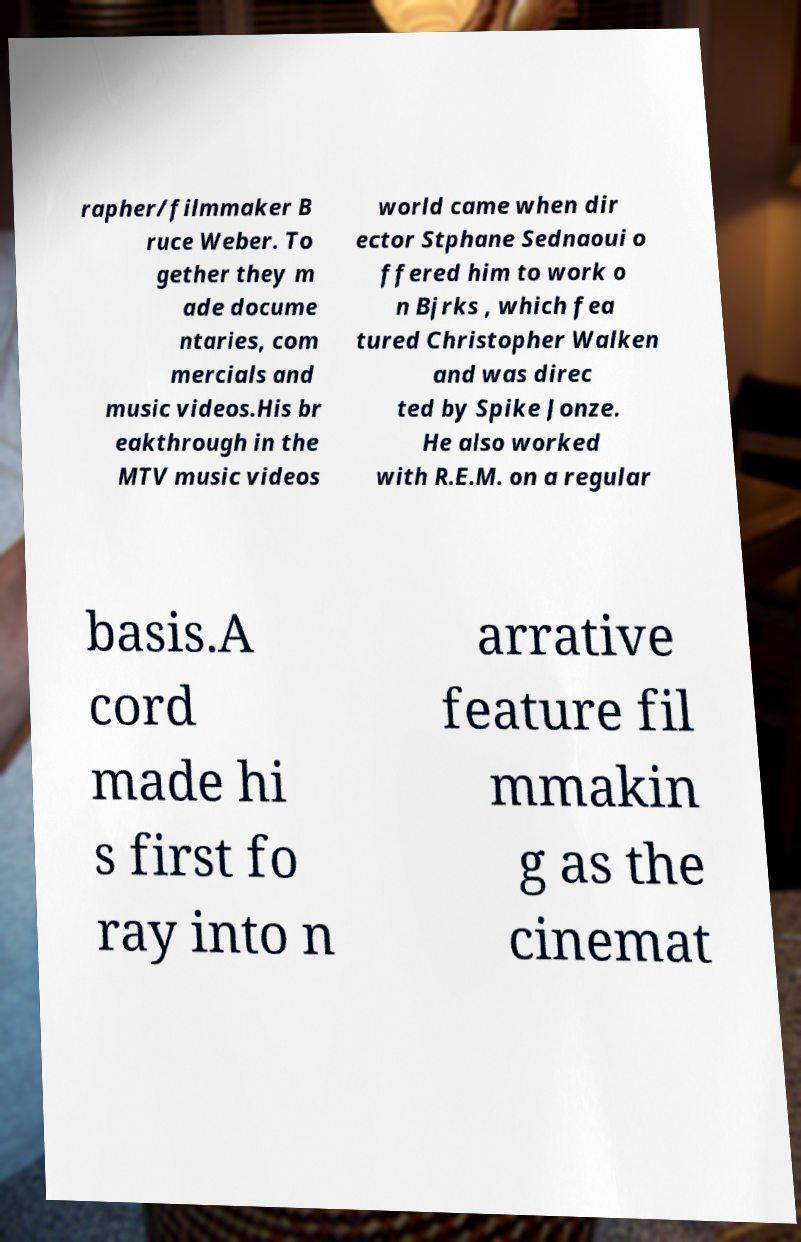What messages or text are displayed in this image? I need them in a readable, typed format. rapher/filmmaker B ruce Weber. To gether they m ade docume ntaries, com mercials and music videos.His br eakthrough in the MTV music videos world came when dir ector Stphane Sednaoui o ffered him to work o n Bjrks , which fea tured Christopher Walken and was direc ted by Spike Jonze. He also worked with R.E.M. on a regular basis.A cord made hi s first fo ray into n arrative feature fil mmakin g as the cinemat 